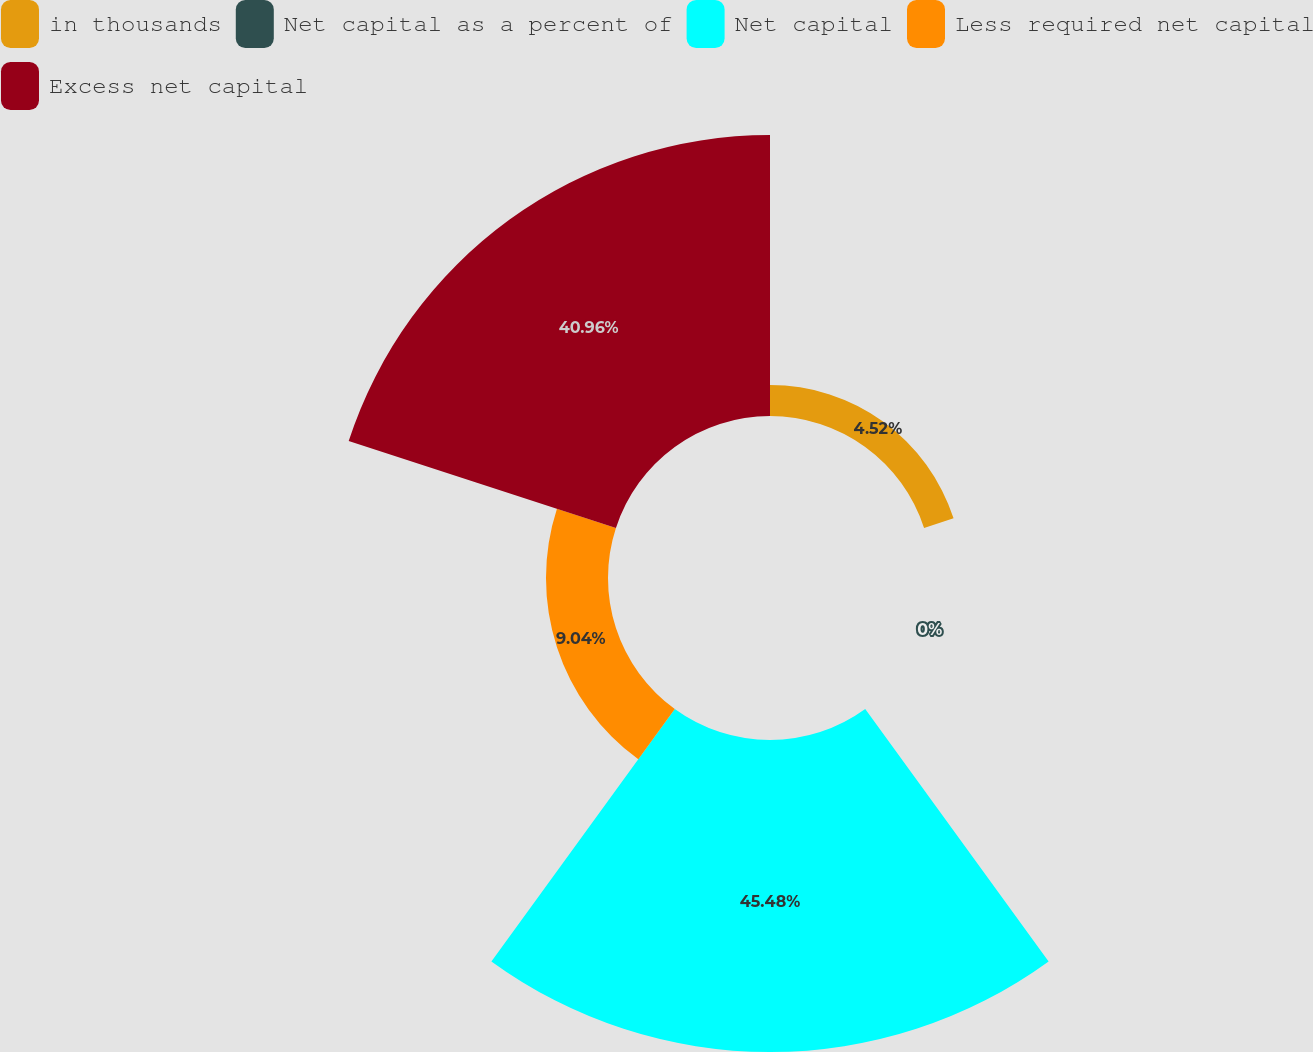Convert chart. <chart><loc_0><loc_0><loc_500><loc_500><pie_chart><fcel>in thousands<fcel>Net capital as a percent of<fcel>Net capital<fcel>Less required net capital<fcel>Excess net capital<nl><fcel>4.52%<fcel>0.0%<fcel>45.48%<fcel>9.04%<fcel>40.96%<nl></chart> 